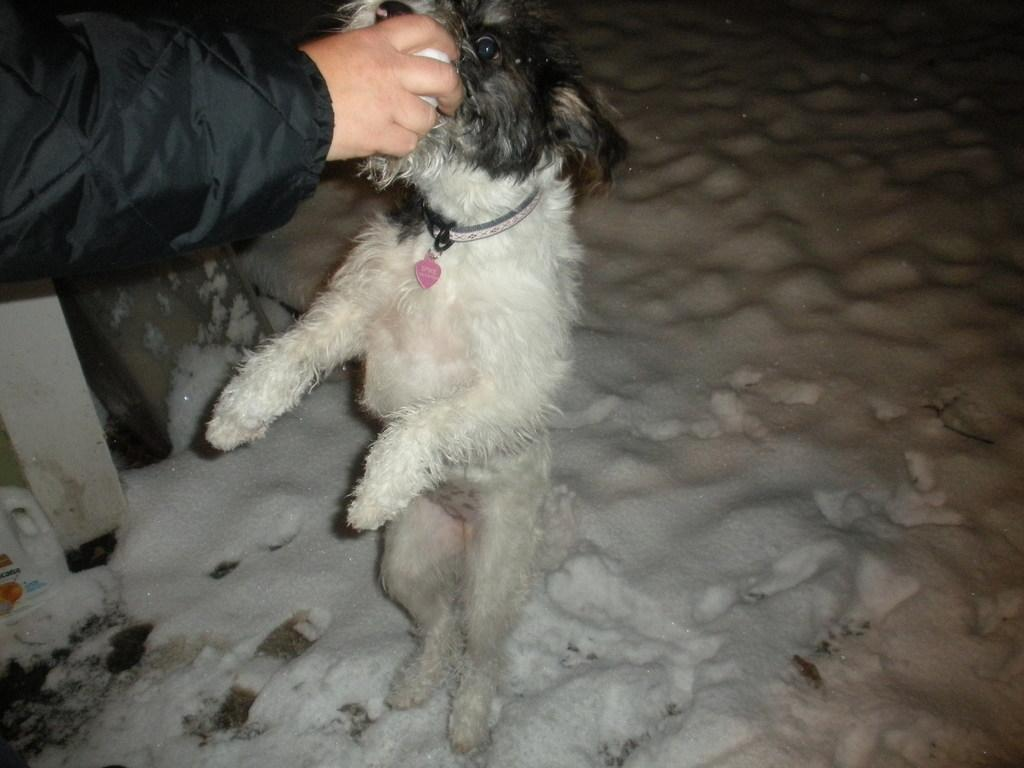What type of animal can be seen in the image? There is a dog in the image. What is the person holding in the image? The person is holding a ball in the image. What material is the pole made of in the image? The pole is made of wood in the image. What is the weather like in the image? There is snow visible in the image, indicating a cold or wintry environment. What type of bike is the person riding in the image? There is no bike present in the image; the person is holding a ball. How does the person rest while holding the ball in the image? The person is not resting in the image; they are holding a ball and interacting with the dog. 